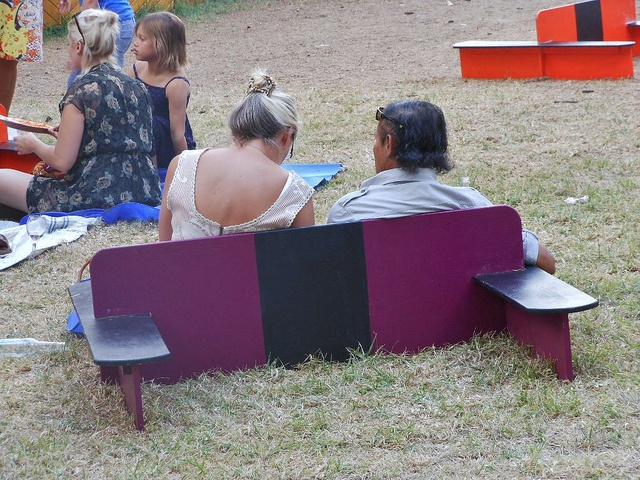Describe the objects in this image and their specific colors. I can see bench in black and purple tones, people in black, gray, navy, darkgray, and darkblue tones, people in black, darkgray, lightgray, and gray tones, people in black, darkgray, gray, and lavender tones, and bench in black, red, brown, white, and darkgray tones in this image. 